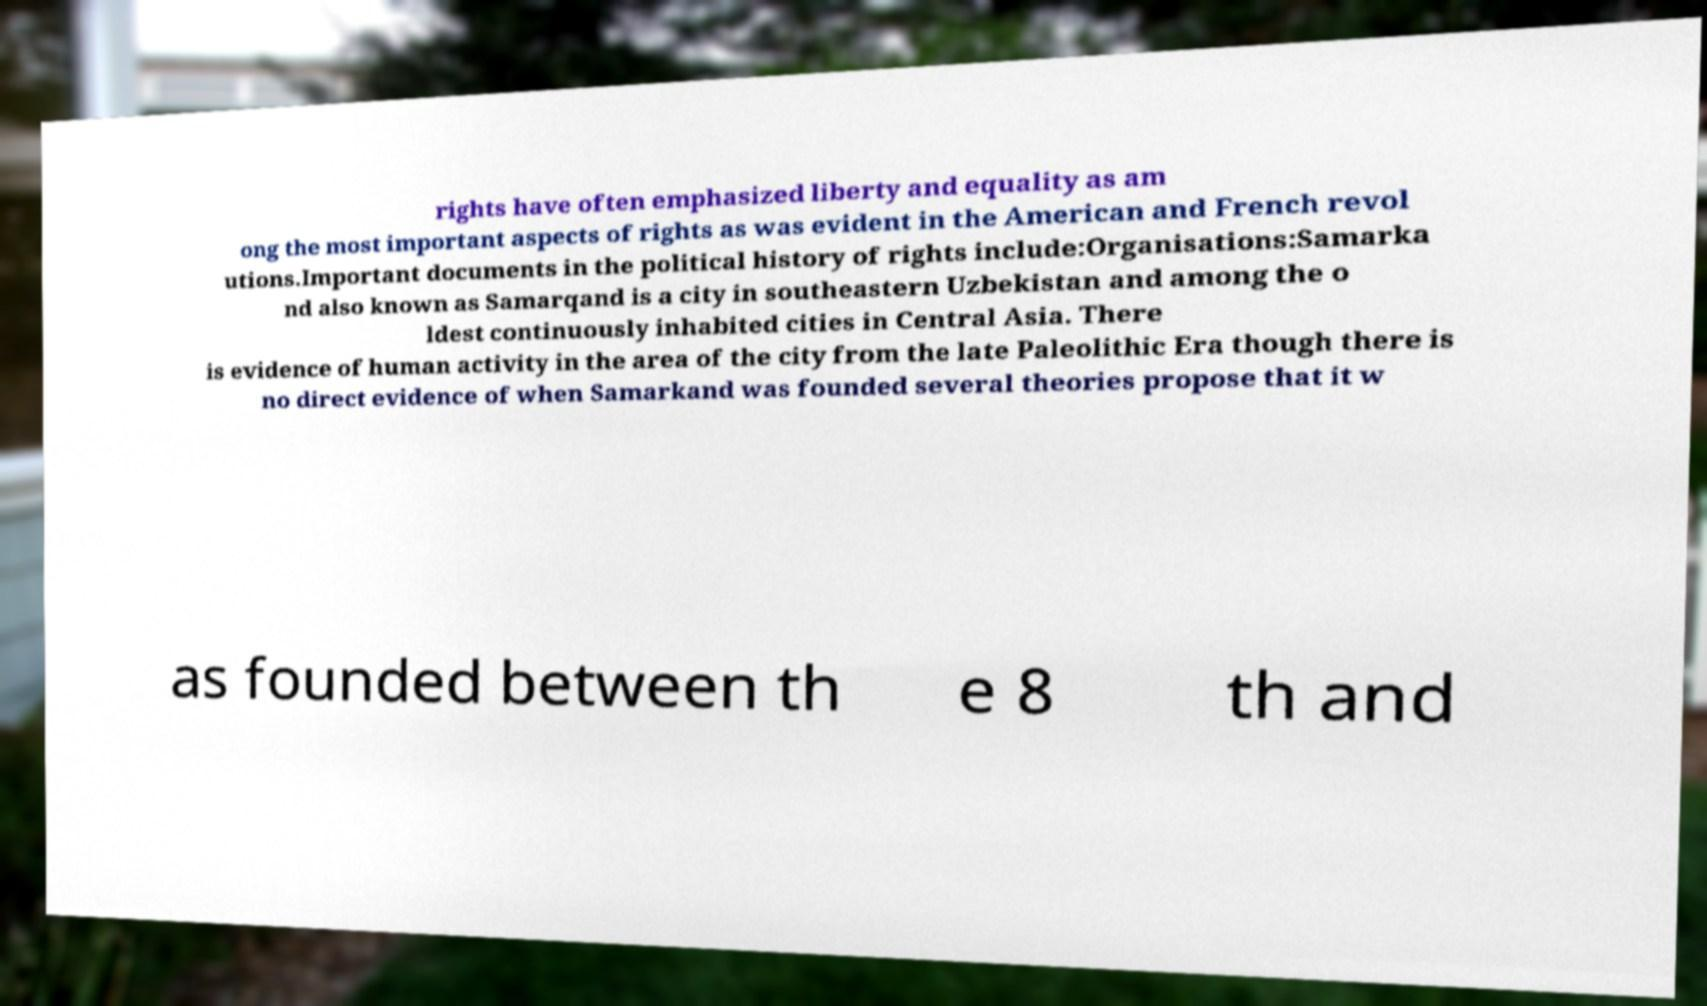For documentation purposes, I need the text within this image transcribed. Could you provide that? rights have often emphasized liberty and equality as am ong the most important aspects of rights as was evident in the American and French revol utions.Important documents in the political history of rights include:Organisations:Samarka nd also known as Samarqand is a city in southeastern Uzbekistan and among the o ldest continuously inhabited cities in Central Asia. There is evidence of human activity in the area of the city from the late Paleolithic Era though there is no direct evidence of when Samarkand was founded several theories propose that it w as founded between th e 8 th and 